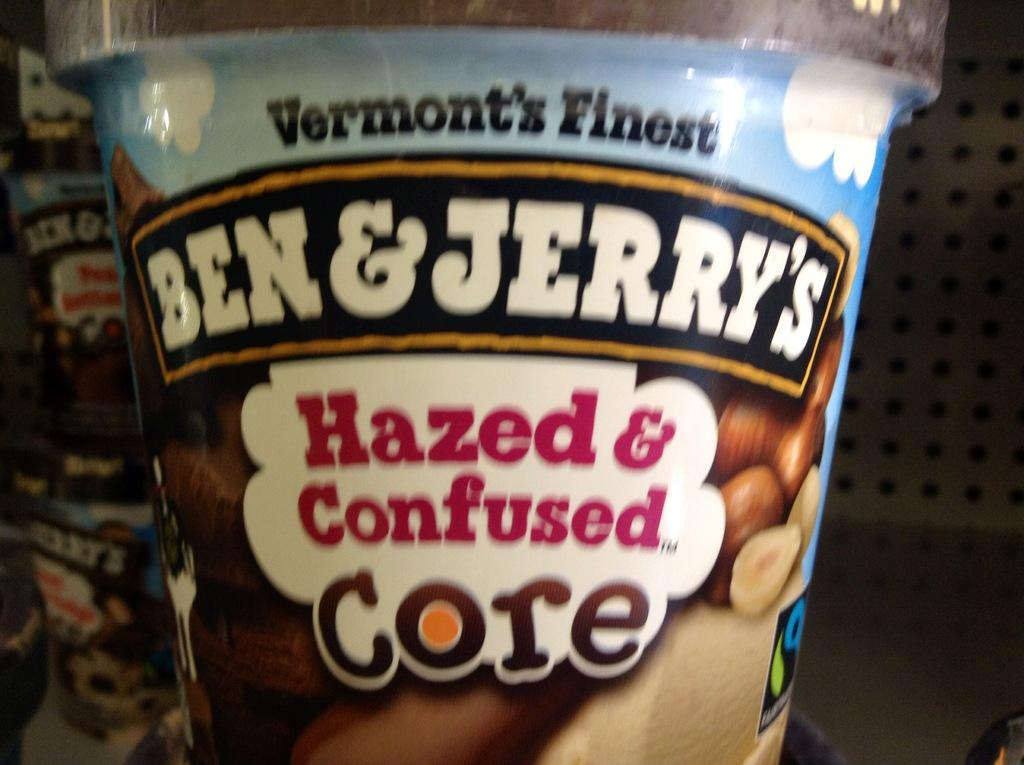What object is present in the image that is typically used for holding nuts? There is a white nut cup in the image. What type of competition is being held near the nut cup in the image? There is no competition present in the image; it only features a white nut cup. Can you tell me how many apples are in the nut cup in the image? There are no apples present in the image; it only features a white nut cup. 